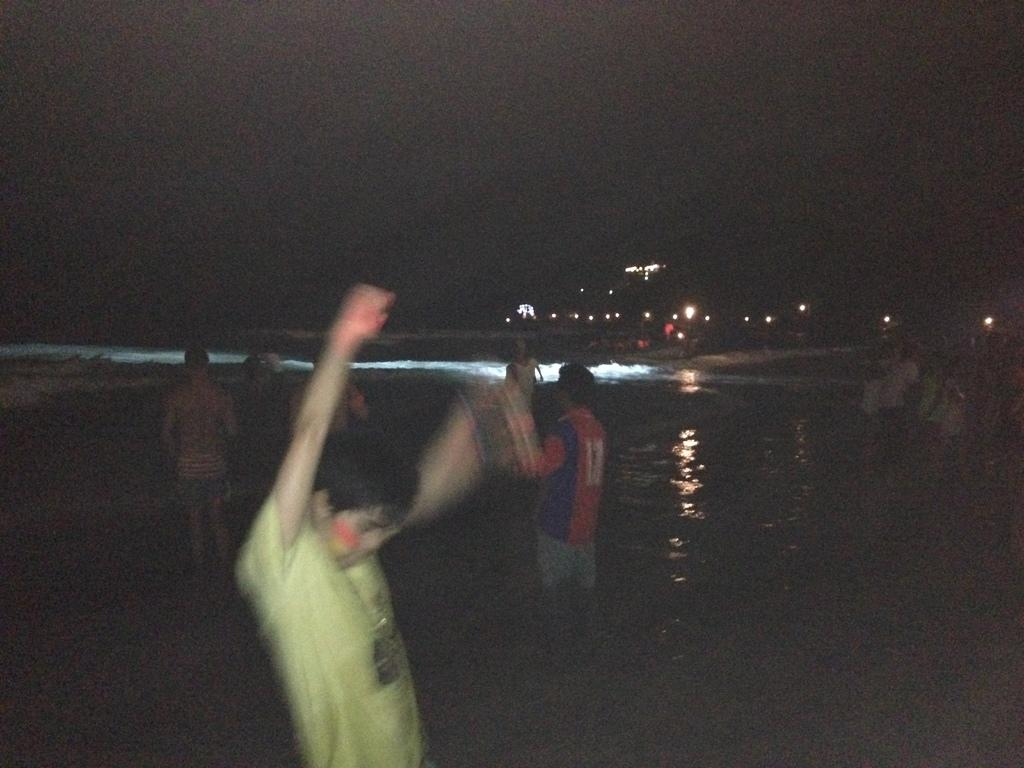How many people are in the image? There are many people in the image. What is visible in the image besides the people? There is water visible in the image. What can be seen in the background of the image? There are lights in the background of the image. How would you describe the overall lighting in the image? The image appears to be dark. Where is the nest located in the image? There is no nest present in the image. 